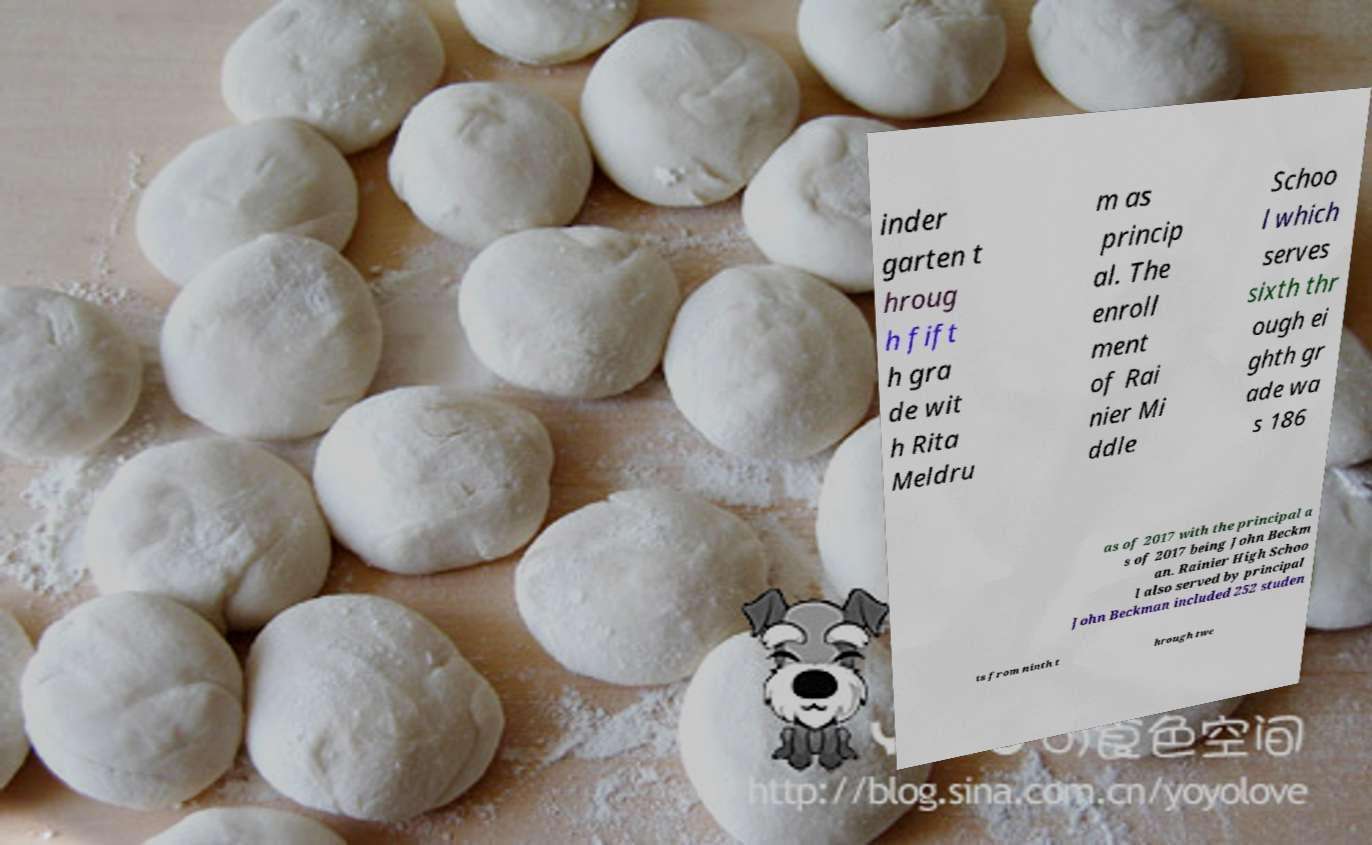Could you extract and type out the text from this image? inder garten t hroug h fift h gra de wit h Rita Meldru m as princip al. The enroll ment of Rai nier Mi ddle Schoo l which serves sixth thr ough ei ghth gr ade wa s 186 as of 2017 with the principal a s of 2017 being John Beckm an. Rainier High Schoo l also served by principal John Beckman included 252 studen ts from ninth t hrough twe 